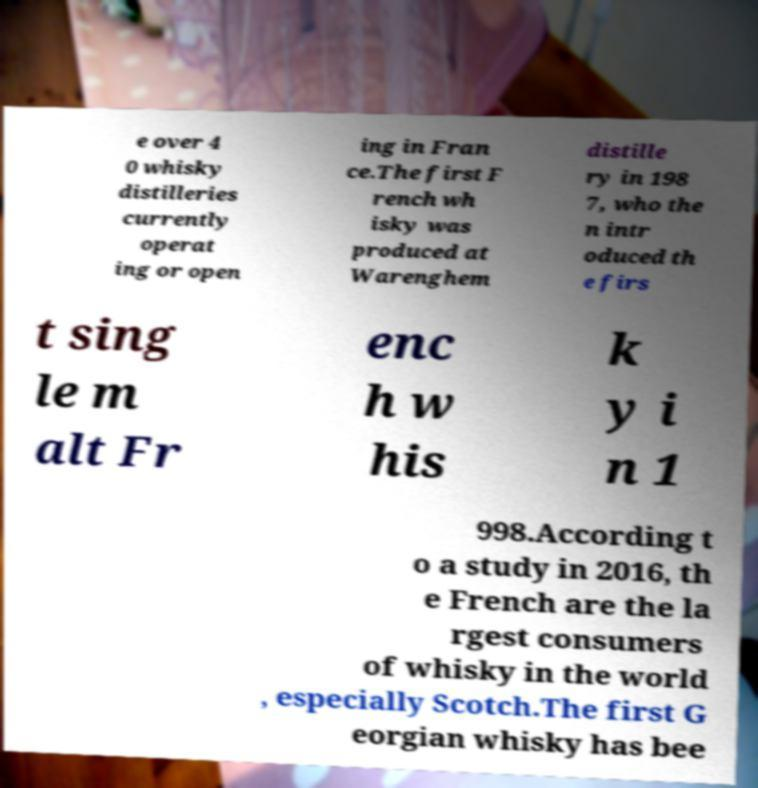Could you assist in decoding the text presented in this image and type it out clearly? e over 4 0 whisky distilleries currently operat ing or open ing in Fran ce.The first F rench wh isky was produced at Warenghem distille ry in 198 7, who the n intr oduced th e firs t sing le m alt Fr enc h w his k y i n 1 998.According t o a study in 2016, th e French are the la rgest consumers of whisky in the world , especially Scotch.The first G eorgian whisky has bee 